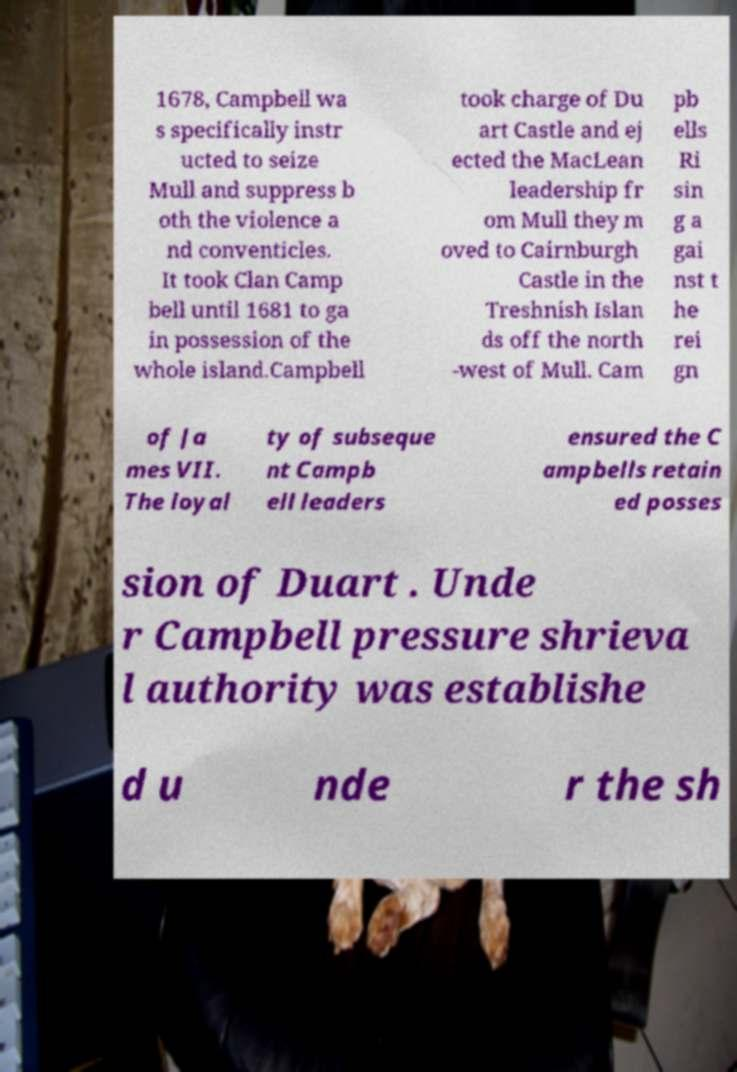For documentation purposes, I need the text within this image transcribed. Could you provide that? 1678, Campbell wa s specifically instr ucted to seize Mull and suppress b oth the violence a nd conventicles. It took Clan Camp bell until 1681 to ga in possession of the whole island.Campbell took charge of Du art Castle and ej ected the MacLean leadership fr om Mull they m oved to Cairnburgh Castle in the Treshnish Islan ds off the north -west of Mull. Cam pb ells Ri sin g a gai nst t he rei gn of Ja mes VII. The loyal ty of subseque nt Campb ell leaders ensured the C ampbells retain ed posses sion of Duart . Unde r Campbell pressure shrieva l authority was establishe d u nde r the sh 